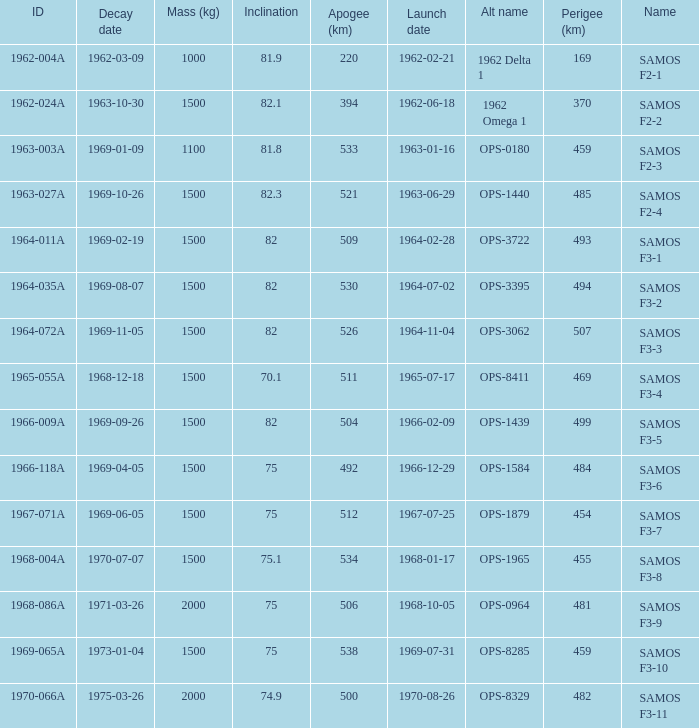What is the maximum apogee for samos f3-3? 526.0. 